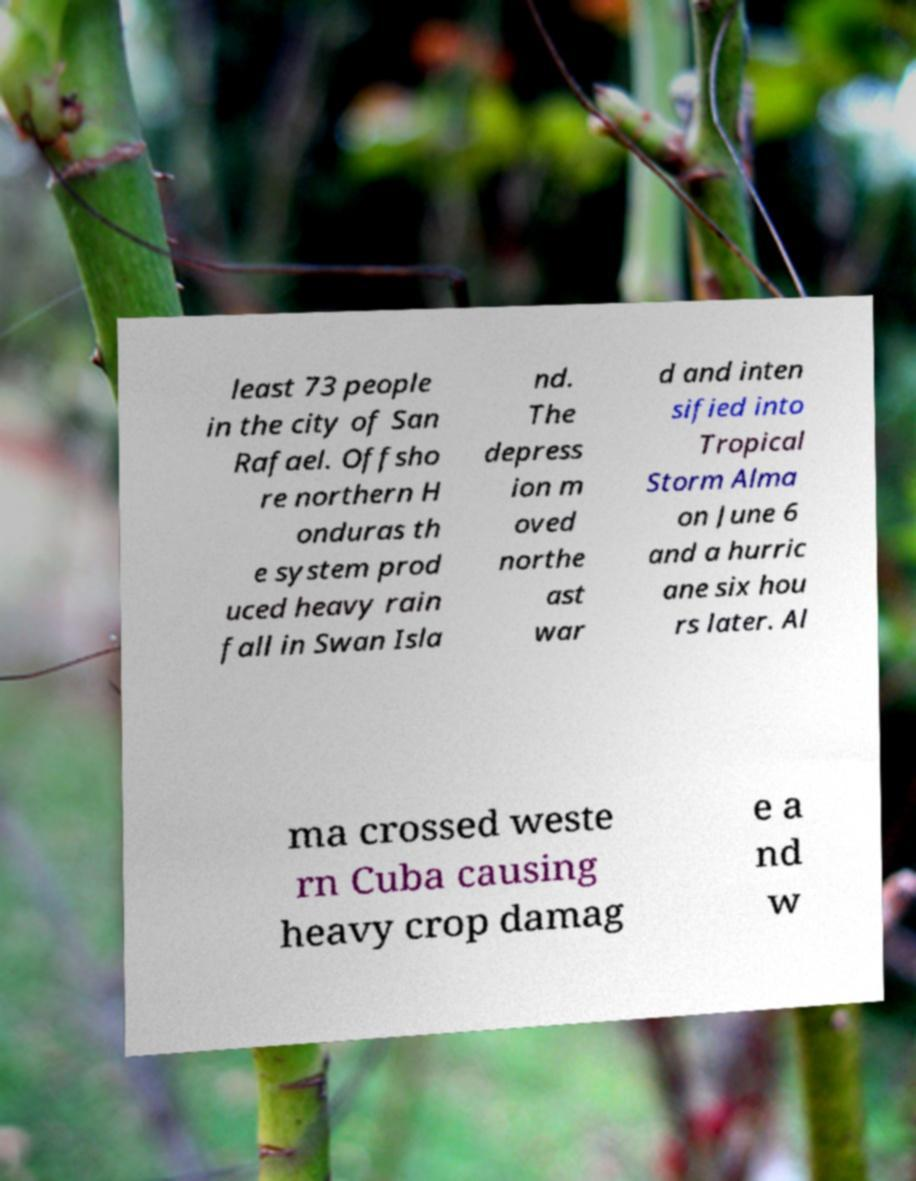Please read and relay the text visible in this image. What does it say? least 73 people in the city of San Rafael. Offsho re northern H onduras th e system prod uced heavy rain fall in Swan Isla nd. The depress ion m oved northe ast war d and inten sified into Tropical Storm Alma on June 6 and a hurric ane six hou rs later. Al ma crossed weste rn Cuba causing heavy crop damag e a nd w 